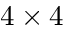Convert formula to latex. <formula><loc_0><loc_0><loc_500><loc_500>4 \times 4</formula> 